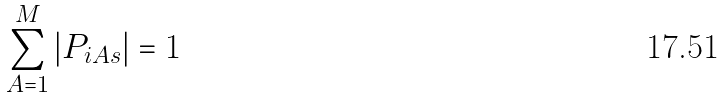Convert formula to latex. <formula><loc_0><loc_0><loc_500><loc_500>\sum _ { A = 1 } ^ { M } | P _ { i A s } | = 1</formula> 